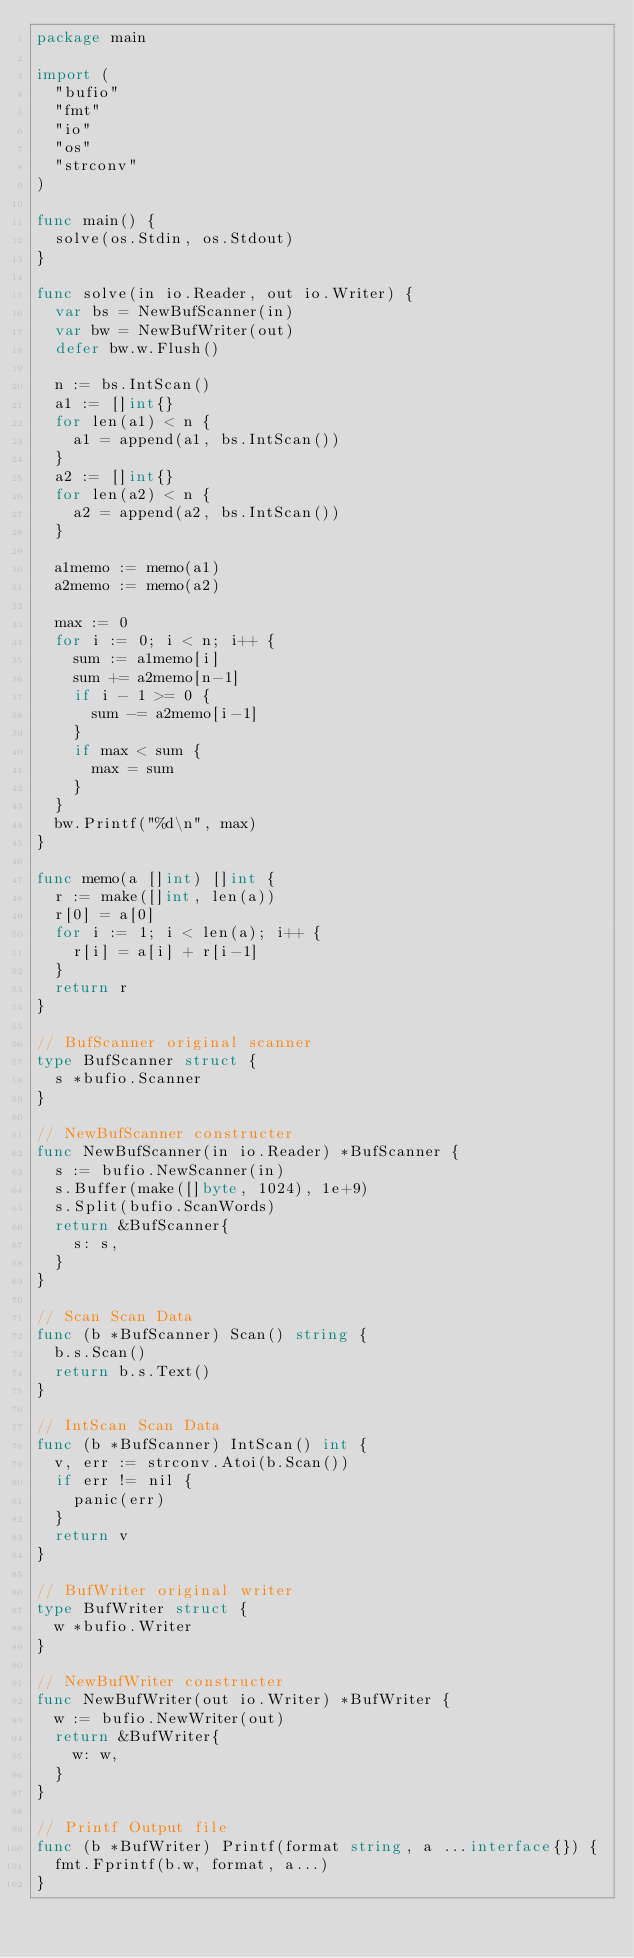Convert code to text. <code><loc_0><loc_0><loc_500><loc_500><_Go_>package main

import (
	"bufio"
	"fmt"
	"io"
	"os"
	"strconv"
)

func main() {
	solve(os.Stdin, os.Stdout)
}

func solve(in io.Reader, out io.Writer) {
	var bs = NewBufScanner(in)
	var bw = NewBufWriter(out)
	defer bw.w.Flush()

	n := bs.IntScan()
	a1 := []int{}
	for len(a1) < n {
		a1 = append(a1, bs.IntScan())
	}
	a2 := []int{}
	for len(a2) < n {
		a2 = append(a2, bs.IntScan())
	}

	a1memo := memo(a1)
	a2memo := memo(a2)

	max := 0
	for i := 0; i < n; i++ {
		sum := a1memo[i]
		sum += a2memo[n-1]
		if i - 1 >= 0 {
			sum -= a2memo[i-1]
		}
		if max < sum {
			max = sum
		}
	}
	bw.Printf("%d\n", max)
}

func memo(a []int) []int {
	r := make([]int, len(a))
	r[0] = a[0]
	for i := 1; i < len(a); i++ {
		r[i] = a[i] + r[i-1]
	}
	return r
}

// BufScanner original scanner
type BufScanner struct {
	s *bufio.Scanner
}

// NewBufScanner constructer
func NewBufScanner(in io.Reader) *BufScanner {
	s := bufio.NewScanner(in)
	s.Buffer(make([]byte, 1024), 1e+9)
	s.Split(bufio.ScanWords)
	return &BufScanner{
		s: s,
	}
}

// Scan Scan Data
func (b *BufScanner) Scan() string {
	b.s.Scan()
	return b.s.Text()
}

// IntScan Scan Data
func (b *BufScanner) IntScan() int {
	v, err := strconv.Atoi(b.Scan())
	if err != nil {
		panic(err)
	}
	return v
}

// BufWriter original writer
type BufWriter struct {
	w *bufio.Writer
}

// NewBufWriter constructer
func NewBufWriter(out io.Writer) *BufWriter {
	w := bufio.NewWriter(out)
	return &BufWriter{
		w: w,
	}
}

// Printf Output file
func (b *BufWriter) Printf(format string, a ...interface{}) {
	fmt.Fprintf(b.w, format, a...)
}</code> 